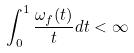Convert formula to latex. <formula><loc_0><loc_0><loc_500><loc_500>\int _ { 0 } ^ { 1 } \frac { \omega _ { f } ( t ) } { t } d t < \infty</formula> 